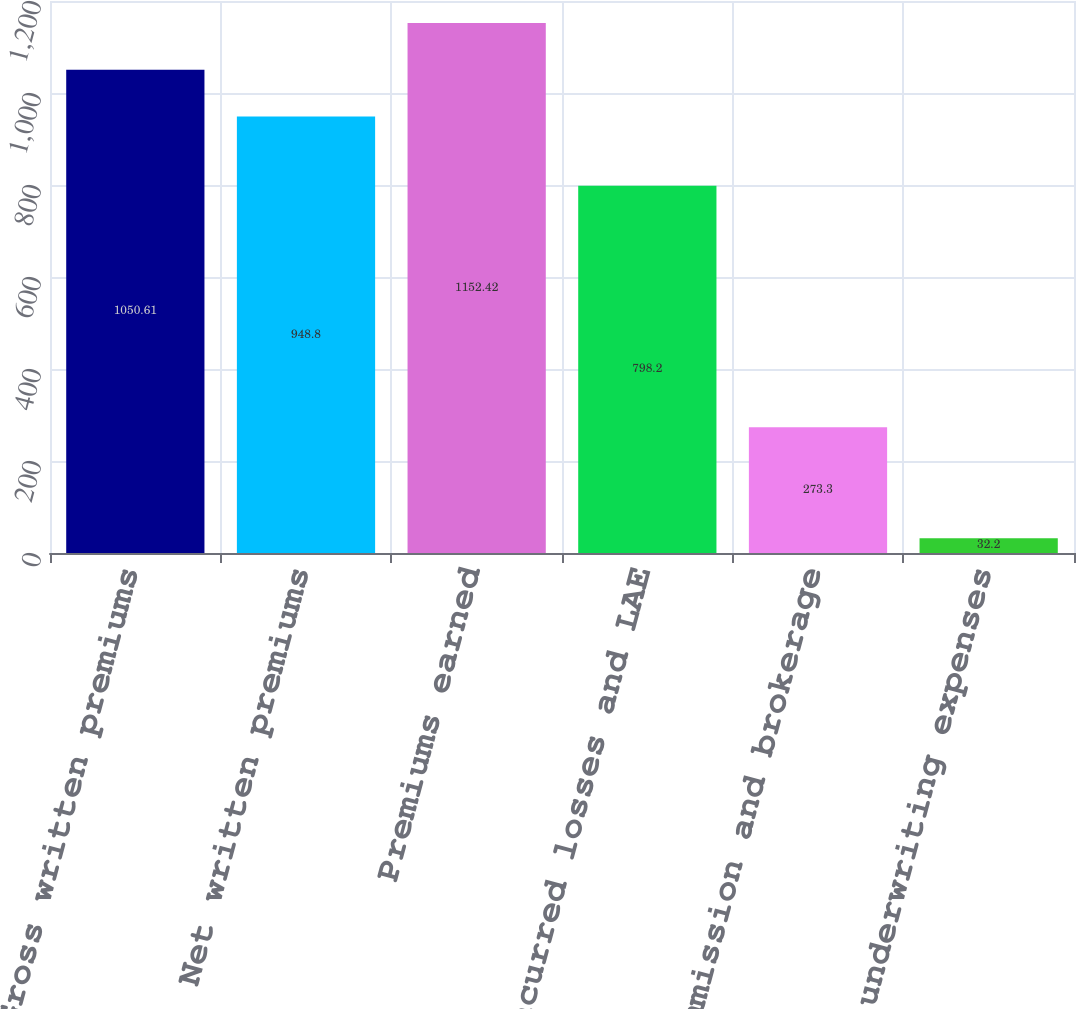<chart> <loc_0><loc_0><loc_500><loc_500><bar_chart><fcel>Gross written premiums<fcel>Net written premiums<fcel>Premiums earned<fcel>Incurred losses and LAE<fcel>Commission and brokerage<fcel>Other underwriting expenses<nl><fcel>1050.61<fcel>948.8<fcel>1152.42<fcel>798.2<fcel>273.3<fcel>32.2<nl></chart> 